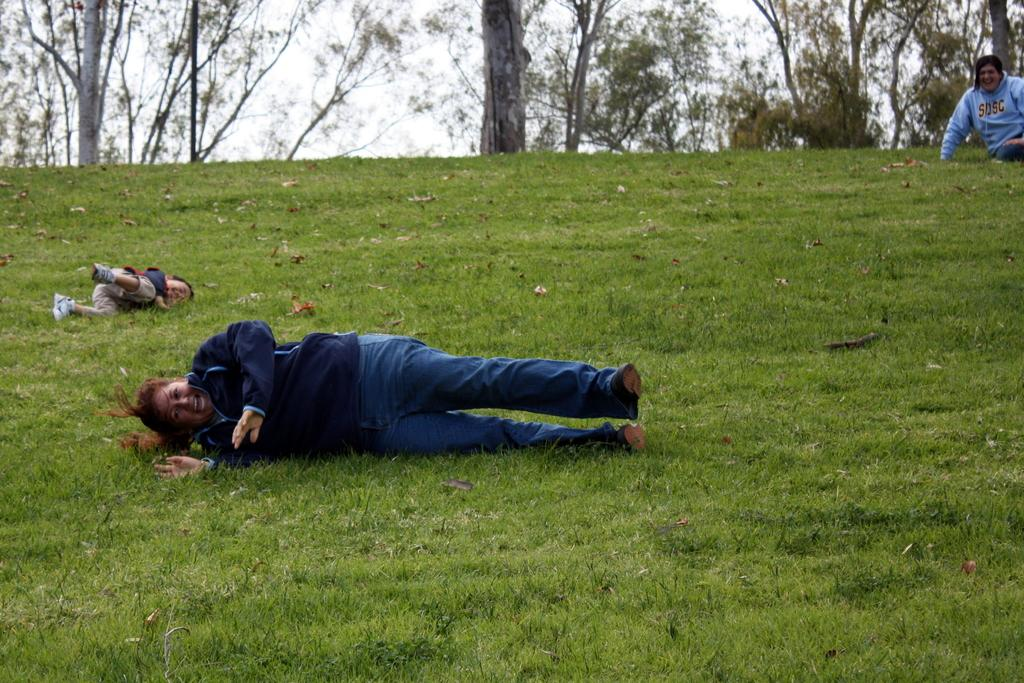Who or what can be seen in the image? There are people in the image. What are some of the people doing in the image? Some people are lying on the ground. What can be seen in the distance in the image? There are trees in the background of the image. What type of action does the wind perform in the image? There is no wind present in the image, so it cannot perform any actions. 